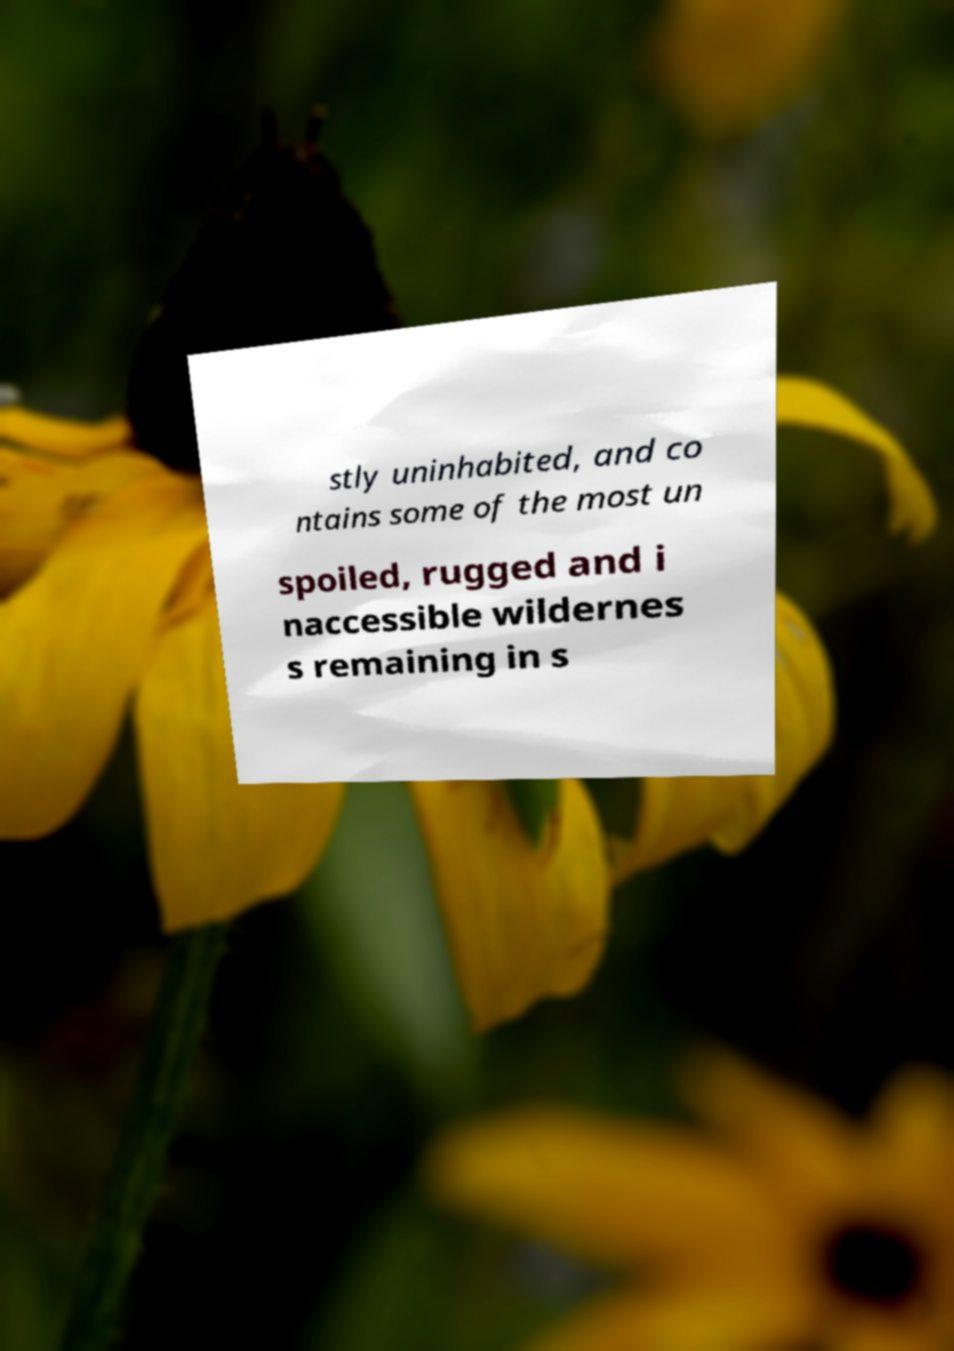Please read and relay the text visible in this image. What does it say? stly uninhabited, and co ntains some of the most un spoiled, rugged and i naccessible wildernes s remaining in s 